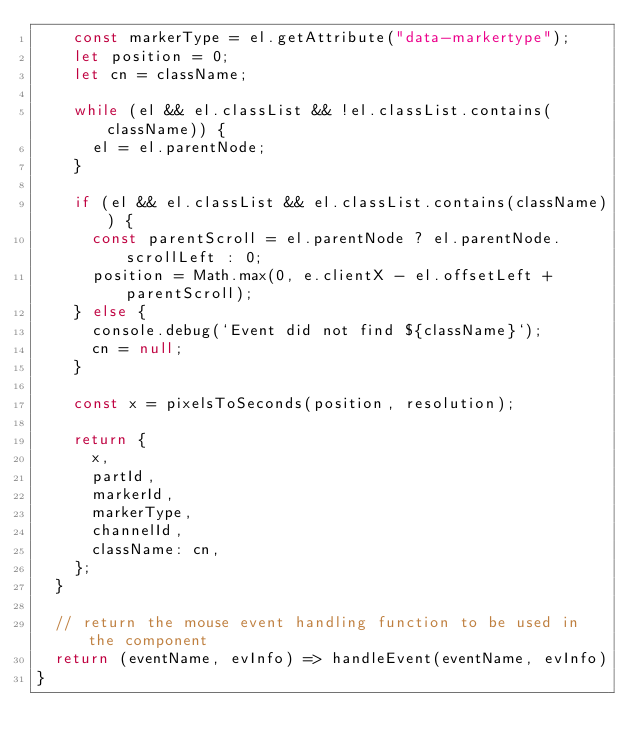Convert code to text. <code><loc_0><loc_0><loc_500><loc_500><_JavaScript_>    const markerType = el.getAttribute("data-markertype");
    let position = 0;
    let cn = className;

    while (el && el.classList && !el.classList.contains(className)) {
      el = el.parentNode;
    }

    if (el && el.classList && el.classList.contains(className)) {
      const parentScroll = el.parentNode ? el.parentNode.scrollLeft : 0;
      position = Math.max(0, e.clientX - el.offsetLeft + parentScroll);
    } else {
      console.debug(`Event did not find ${className}`);
      cn = null;
    }

    const x = pixelsToSeconds(position, resolution);

    return {
      x,
      partId,
      markerId,
      markerType,
      channelId,
      className: cn,
    };
  }

  // return the mouse event handling function to be used in the component
  return (eventName, evInfo) => handleEvent(eventName, evInfo)
}</code> 